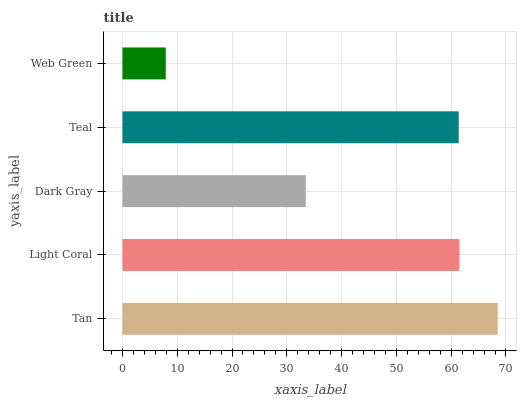Is Web Green the minimum?
Answer yes or no. Yes. Is Tan the maximum?
Answer yes or no. Yes. Is Light Coral the minimum?
Answer yes or no. No. Is Light Coral the maximum?
Answer yes or no. No. Is Tan greater than Light Coral?
Answer yes or no. Yes. Is Light Coral less than Tan?
Answer yes or no. Yes. Is Light Coral greater than Tan?
Answer yes or no. No. Is Tan less than Light Coral?
Answer yes or no. No. Is Teal the high median?
Answer yes or no. Yes. Is Teal the low median?
Answer yes or no. Yes. Is Dark Gray the high median?
Answer yes or no. No. Is Web Green the low median?
Answer yes or no. No. 